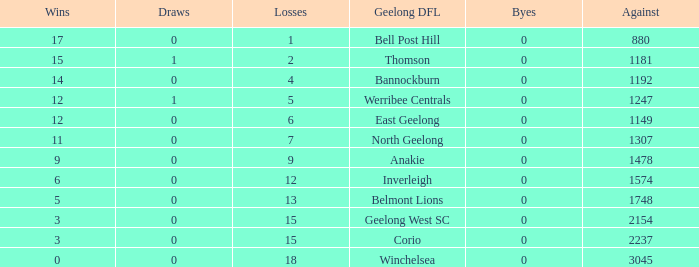What is the lowest number of wins where the byes are less than 0? None. 